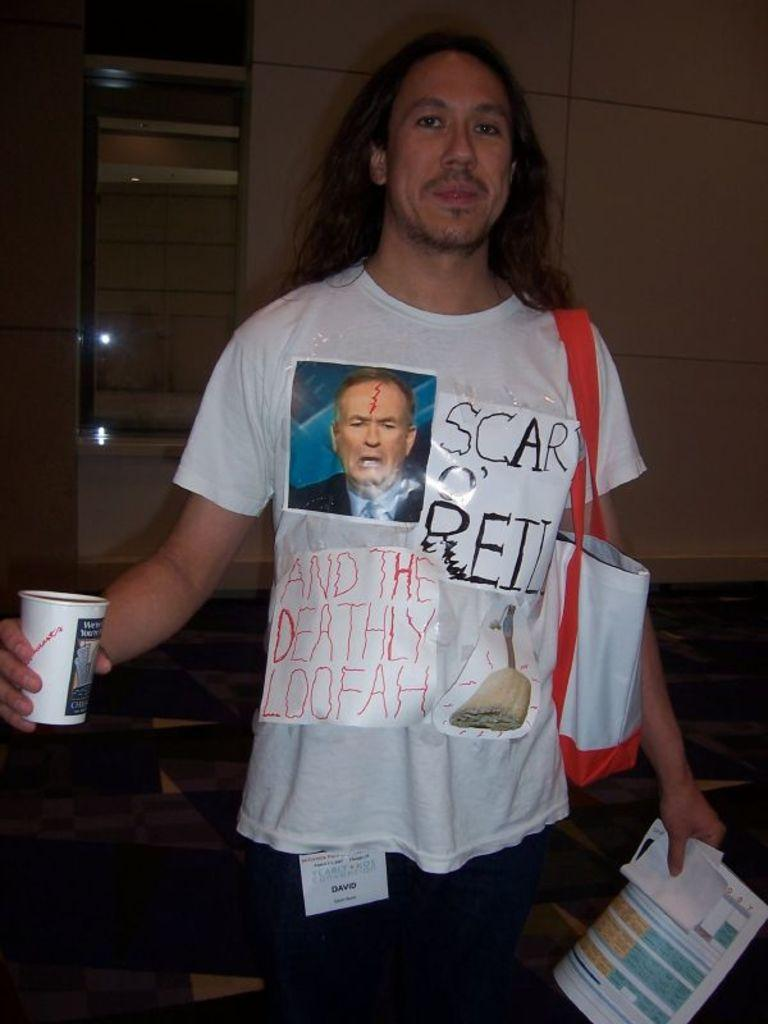<image>
Summarize the visual content of the image. The word scar is visible on a man's tee shirt. 